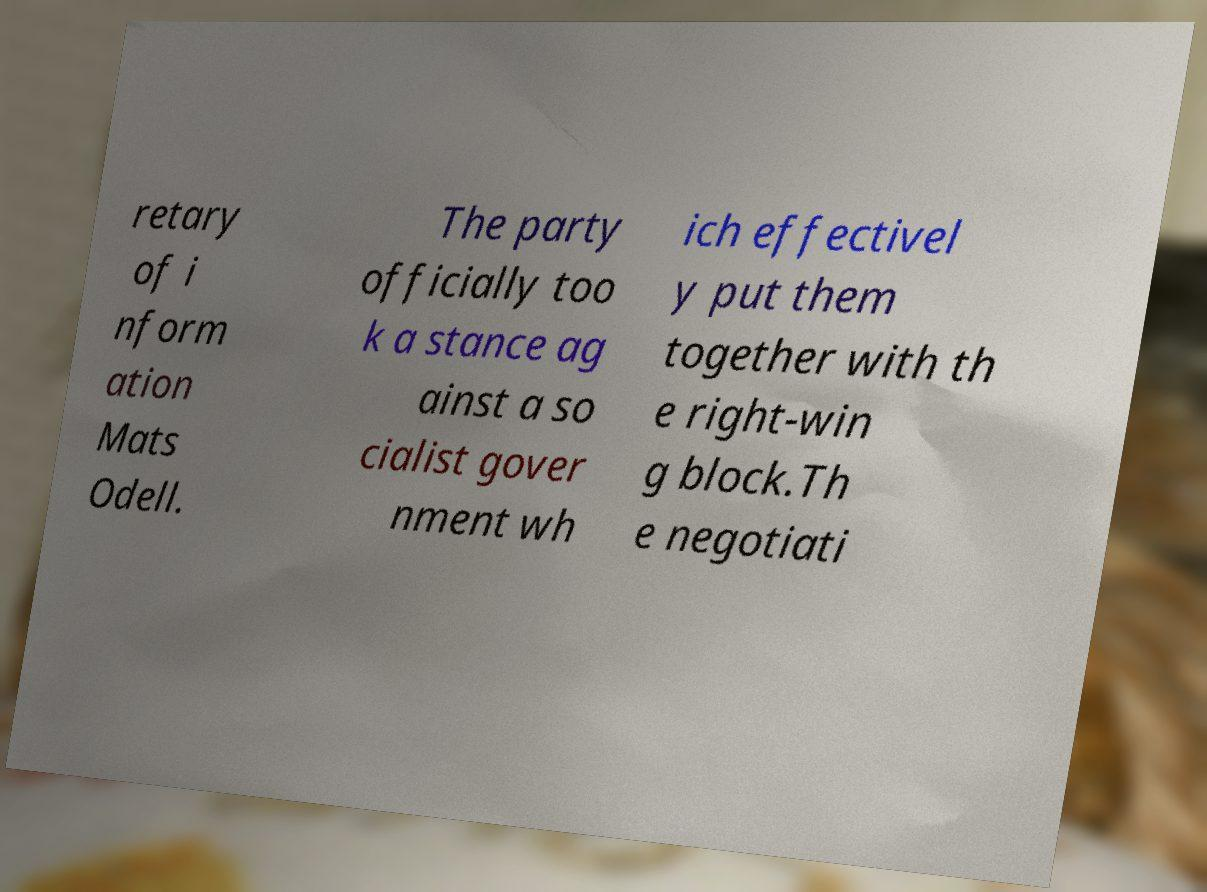Please identify and transcribe the text found in this image. retary of i nform ation Mats Odell. The party officially too k a stance ag ainst a so cialist gover nment wh ich effectivel y put them together with th e right-win g block.Th e negotiati 